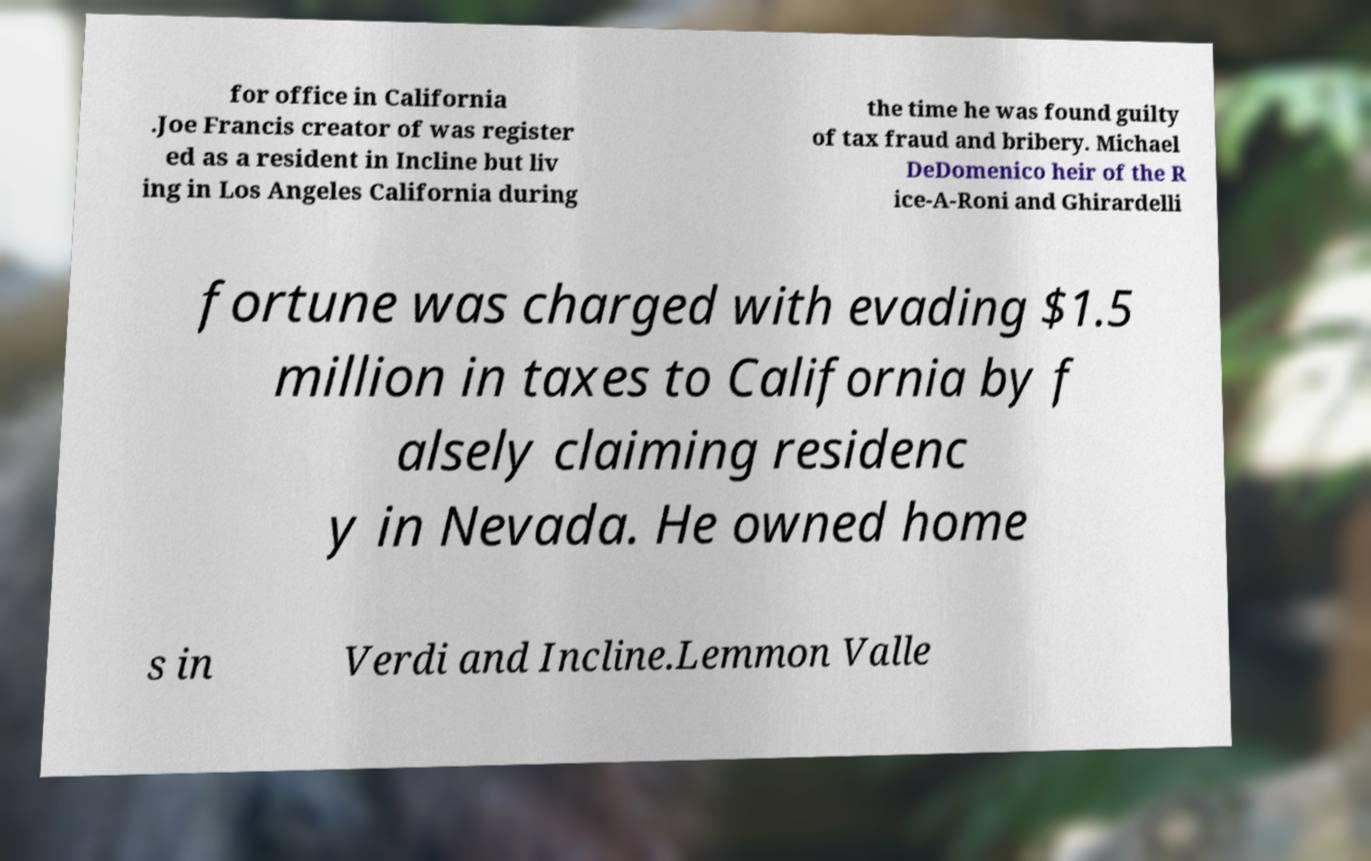What messages or text are displayed in this image? I need them in a readable, typed format. for office in California .Joe Francis creator of was register ed as a resident in Incline but liv ing in Los Angeles California during the time he was found guilty of tax fraud and bribery. Michael DeDomenico heir of the R ice-A-Roni and Ghirardelli fortune was charged with evading $1.5 million in taxes to California by f alsely claiming residenc y in Nevada. He owned home s in Verdi and Incline.Lemmon Valle 